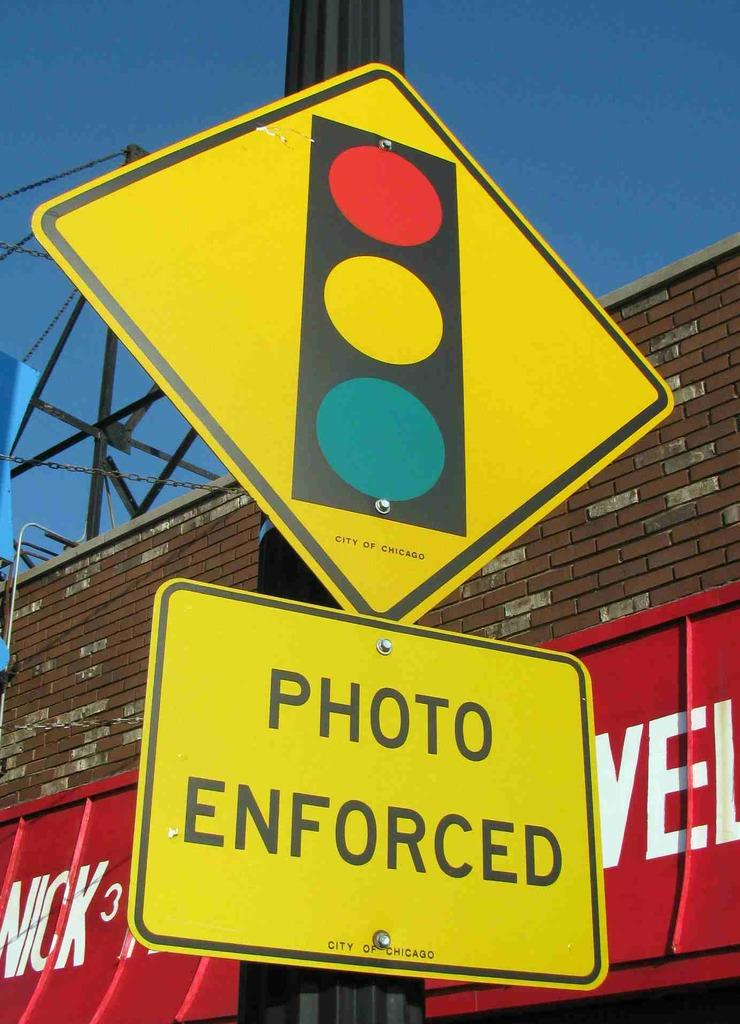What is the main object in the image? There is a board in the image. What other structures or objects can be seen in the image? There is a pole, a building, and metal rods present in the image. What is visible in the background of the image? The sky is visible in the image. Can you determine the time of day the image was taken? The image might have been taken during the day, but there is no definitive indication of the time. What type of wren can be seen perched on the produce in the image? There is no wren or produce present in the image; it features a board, pole, building, metal rods, and the sky. What kind of oatmeal is being prepared in the image? There is no oatmeal or preparation activity present in the image. 